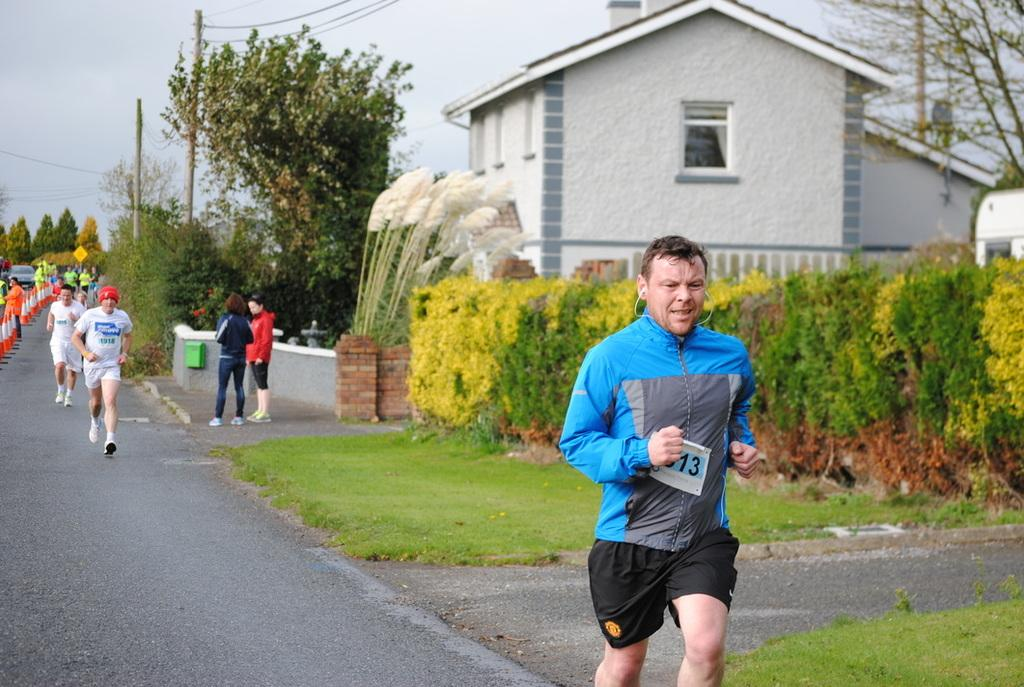What type of vegetation can be seen in the image? There is grass, plants, and trees in the image. Are there any living beings present in the image? Yes, there are people in the image. What objects are used to direct traffic in the image? Traffic cones are present in the image. What type of structure can be seen in the image? There is a house in the image. What part of the natural environment is visible in the image? The sky is visible in the image. What type of chess pieces can be seen on the canvas in the image? There is no chess or canvas present in the image. What type of gate is visible in the image? There is no gate present in the image. 